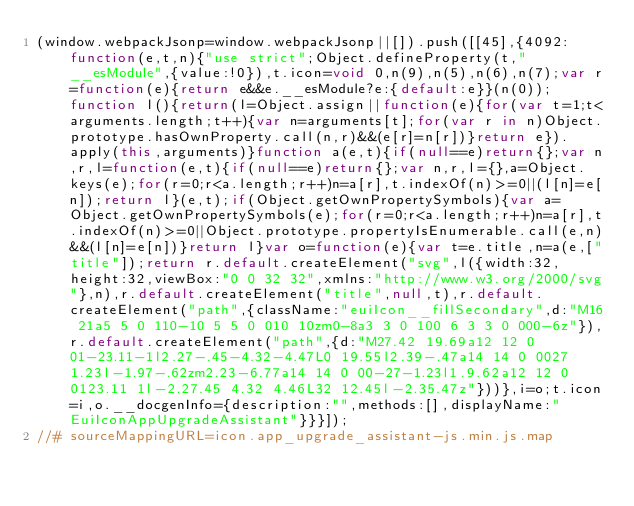<code> <loc_0><loc_0><loc_500><loc_500><_JavaScript_>(window.webpackJsonp=window.webpackJsonp||[]).push([[45],{4092:function(e,t,n){"use strict";Object.defineProperty(t,"__esModule",{value:!0}),t.icon=void 0,n(9),n(5),n(6),n(7);var r=function(e){return e&&e.__esModule?e:{default:e}}(n(0));function l(){return(l=Object.assign||function(e){for(var t=1;t<arguments.length;t++){var n=arguments[t];for(var r in n)Object.prototype.hasOwnProperty.call(n,r)&&(e[r]=n[r])}return e}).apply(this,arguments)}function a(e,t){if(null==e)return{};var n,r,l=function(e,t){if(null==e)return{};var n,r,l={},a=Object.keys(e);for(r=0;r<a.length;r++)n=a[r],t.indexOf(n)>=0||(l[n]=e[n]);return l}(e,t);if(Object.getOwnPropertySymbols){var a=Object.getOwnPropertySymbols(e);for(r=0;r<a.length;r++)n=a[r],t.indexOf(n)>=0||Object.prototype.propertyIsEnumerable.call(e,n)&&(l[n]=e[n])}return l}var o=function(e){var t=e.title,n=a(e,["title"]);return r.default.createElement("svg",l({width:32,height:32,viewBox:"0 0 32 32",xmlns:"http://www.w3.org/2000/svg"},n),r.default.createElement("title",null,t),r.default.createElement("path",{className:"euiIcon__fillSecondary",d:"M16 21a5 5 0 110-10 5 5 0 010 10zm0-8a3 3 0 100 6 3 3 0 000-6z"}),r.default.createElement("path",{d:"M27.42 19.69a12 12 0 01-23.11-1l2.27-.45-4.32-4.47L0 19.55l2.39-.47a14 14 0 0027 1.23l-1.97-.62zm2.23-6.77a14 14 0 00-27-1.23l1.9.62a12 12 0 0123.11 1l-2.27.45 4.32 4.46L32 12.45l-2.35.47z"}))},i=o;t.icon=i,o.__docgenInfo={description:"",methods:[],displayName:"EuiIconAppUpgradeAssistant"}}}]);
//# sourceMappingURL=icon.app_upgrade_assistant-js.min.js.map</code> 